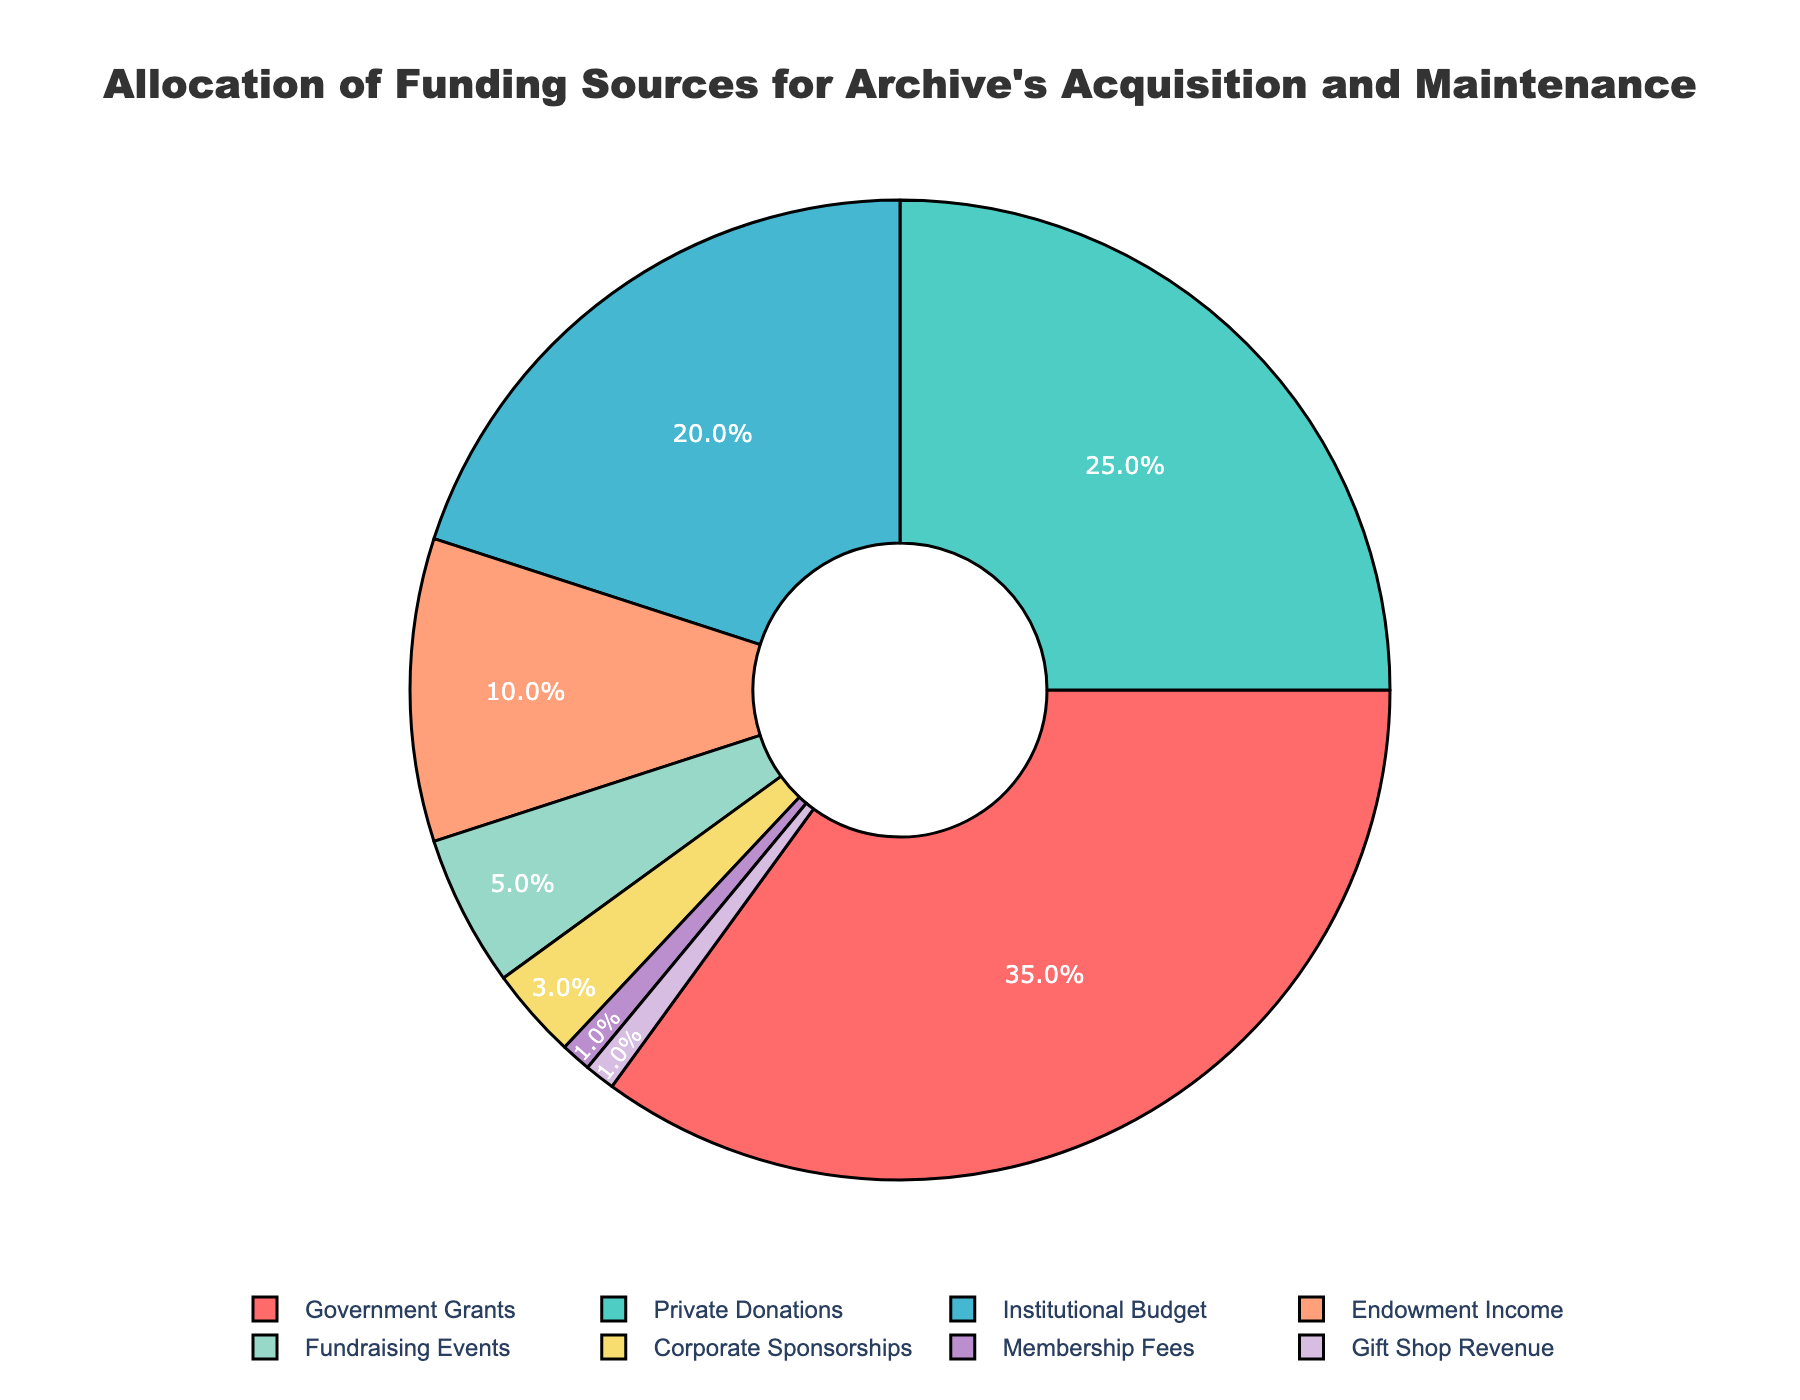What percentage of the funding comes from Government Grants? The Government Grants segment on the pie chart is labeled with "35%". This label indicates that 35% of the funding comes from Government Grants.
Answer: 35% Which funding source has the smallest percentage, and what is it? According to the pie chart, the segments for Membership Fees and Gift Shop Revenue are both labeled with "1%", indicating that they share the smallest percentage.
Answer: Membership Fees and Gift Shop Revenue, 1% How much larger is the percentage of Government Grants compared to Endowment Income? The percentage for Government Grants is 35%, and for Endowment Income, it is 10%. Subtracting the two percentages: 35% - 10% = 25%.
Answer: 25% Which two funding sources combined make up more than half of the total funding? The percentages for Government Grants and Private Donations are 35% and 25%, respectively. Adding them together: 35% + 25% = 60%, which is more than half.
Answer: Government Grants and Private Donations What is the combined percentage of all funding sources that contribute less than 10% individually? The relevant funding sources are Endowment Income (10%), Fundraising Events (5%), Corporate Sponsorships (3%), Membership Fees (1%), and Gift Shop Revenue (1%). Adding these percentages: 10% + 5% + 3% + 1% + 1% = 20%.
Answer: 20% Is the percentage of Private Donations greater than Institutional Budget? If so, by how much? The percentage for Private Donations is 25% and for Institutional Budget is 20%. Subtracting the two percentages: 25% - 20% = 5%.
Answer: Yes, by 5% Which funding sources are represented by shades of blue, and what are their percentages? In the pie chart, the shades of blue are used for the Institutional Budget (20%) and Endowment Income (10%).
Answer: Institutional Budget (20%) and Endowment Income (10%) Are the combined percentages of Corporate Sponsorships and Membership Fees greater than Fundraising Events? Corporate Sponsorships contribute 3% and Membership Fees contribute 1%. Adding them together: 3% + 1% = 4%, which is less than Fundraising Events at 5%.
Answer: No What proportion of the funding comes from non-governmental sources? The total percentage is 100%. Subtracting Government Grants (35%) from the total: 100% - 35% = 65%.
Answer: 65% How much more of the funding is sourced from Government Grants and Private Donations together than from all other sources combined? Government Grants and Private Donations together account for 35% + 25% = 60%. The sum of the remaining sources is 100% - 60% = 40%. The difference is 60% - 40% = 20%.
Answer: 20% 